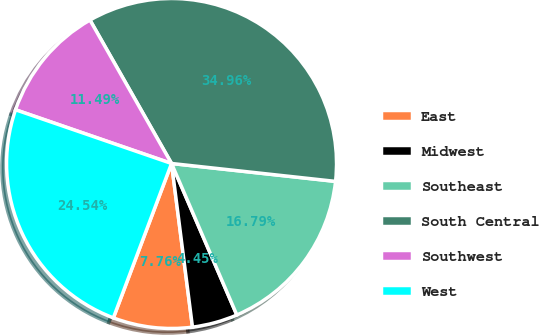Convert chart. <chart><loc_0><loc_0><loc_500><loc_500><pie_chart><fcel>East<fcel>Midwest<fcel>Southeast<fcel>South Central<fcel>Southwest<fcel>West<nl><fcel>7.76%<fcel>4.45%<fcel>16.79%<fcel>34.96%<fcel>11.49%<fcel>24.54%<nl></chart> 